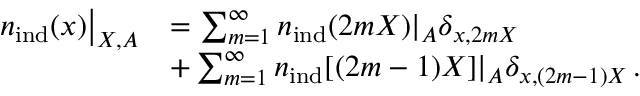Convert formula to latex. <formula><loc_0><loc_0><loc_500><loc_500>\begin{array} { r l } { { n } _ { i n d } ( x ) \right | _ { X , A } } & { = \sum _ { m = 1 } ^ { \infty } { n } _ { i n d } ( 2 m X ) | _ { A } \delta _ { x , 2 m X } } \\ & { + \sum _ { m = 1 } ^ { \infty } { n } _ { i n d } [ ( 2 m - 1 ) X ] | _ { A } \delta _ { x , ( 2 m - 1 ) X } \, . } \end{array}</formula> 